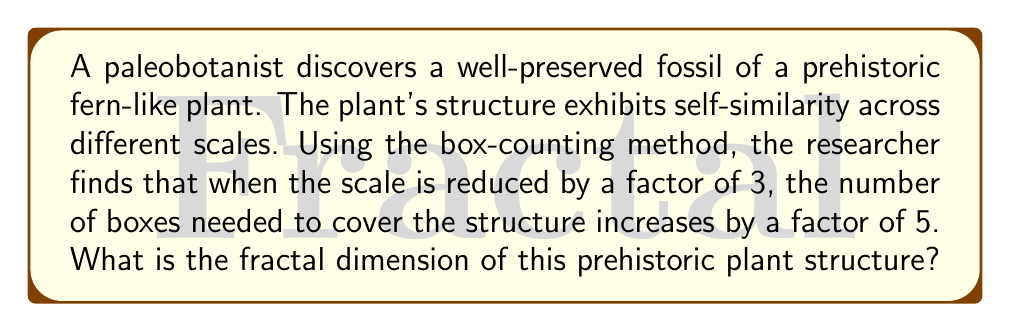What is the answer to this math problem? To solve this problem, we'll use the concept of fractal dimension and the box-counting method. The fractal dimension (D) is given by the formula:

$$ D = \frac{\log N}{\log (1/r)} $$

Where:
- N is the number of self-similar pieces
- r is the scaling factor

In this case:
1. The scaling factor (r) is 1/3, as the scale is reduced by a factor of 3.
2. The number of self-similar pieces (N) is 5, as the number of boxes increases by a factor of 5.

Let's plug these values into the formula:

$$ D = \frac{\log 5}{\log (1/(1/3))} = \frac{\log 5}{\log 3} $$

Using a calculator or computer to evaluate this:

$$ D \approx 1.4650 $$

This fractal dimension lies between 1 and 2, which is typical for many plant structures. It suggests that the prehistoric fern-like plant has a complexity greater than a simple line (dimension 1) but less than a filled plane (dimension 2).
Answer: $\frac{\log 5}{\log 3} \approx 1.4650$ 